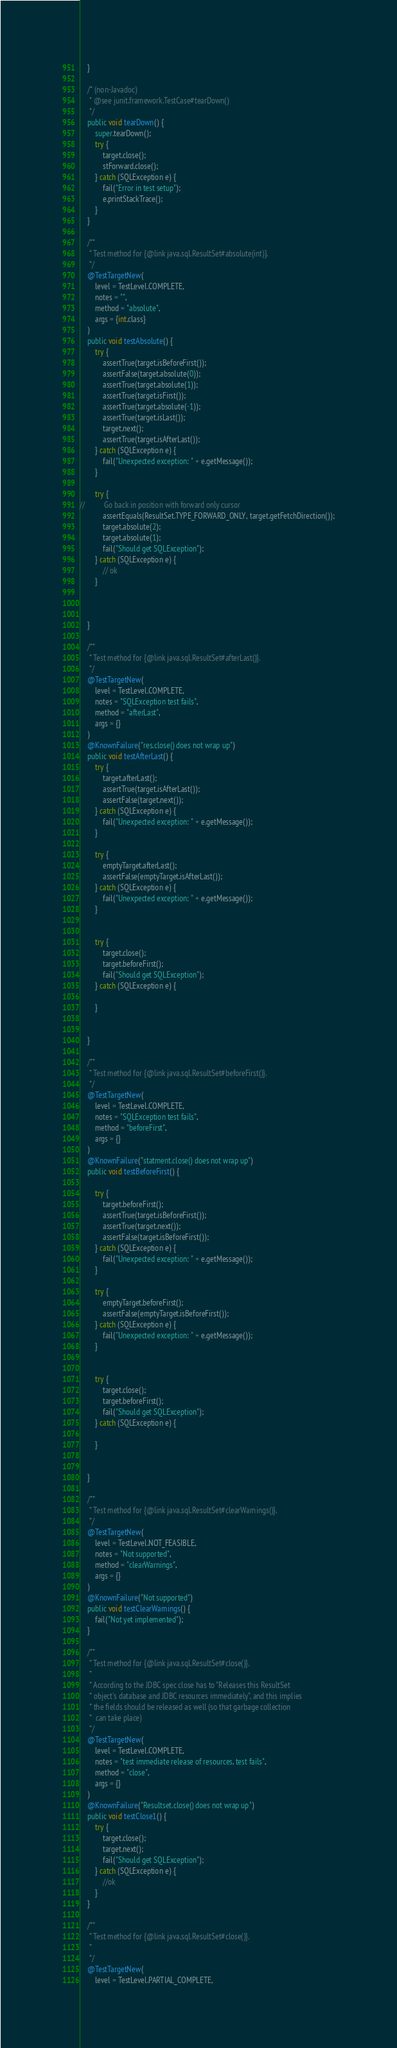<code> <loc_0><loc_0><loc_500><loc_500><_Java_>    }

    /* (non-Javadoc)
     * @see junit.framework.TestCase#tearDown()
     */
    public void tearDown() {
        super.tearDown();
        try {
            target.close();
            stForward.close();
        } catch (SQLException e) {
            fail("Error in test setup");
            e.printStackTrace();
        }
    }

    /**
     * Test method for {@link java.sql.ResultSet#absolute(int)}.
     */
    @TestTargetNew(
        level = TestLevel.COMPLETE,
        notes = "",
        method = "absolute",
        args = {int.class}
    )
    public void testAbsolute() {
        try {
            assertTrue(target.isBeforeFirst());
            assertFalse(target.absolute(0));
            assertTrue(target.absolute(1));
            assertTrue(target.isFirst());
            assertTrue(target.absolute(-1));
            assertTrue(target.isLast());
            target.next();
            assertTrue(target.isAfterLast());
        } catch (SQLException e) {
            fail("Unexpected exception: " + e.getMessage());
        }
        
        try {
//          Go back in position with forward only cursor
            assertEquals(ResultSet.TYPE_FORWARD_ONLY, target.getFetchDirection());
            target.absolute(2);
            target.absolute(1);
            fail("Should get SQLException");
        } catch (SQLException e) {
            // ok
        }
        
        
        
    }

    /**
     * Test method for {@link java.sql.ResultSet#afterLast()}.
     */
    @TestTargetNew(
        level = TestLevel.COMPLETE,
        notes = "SQLException test fails",
        method = "afterLast",
        args = {}
    )
    @KnownFailure("res.close() does not wrap up")
    public void testAfterLast() {
        try {
            target.afterLast();
            assertTrue(target.isAfterLast());
            assertFalse(target.next());
        } catch (SQLException e) {
            fail("Unexpected exception: " + e.getMessage());
        }
        
        try {
            emptyTarget.afterLast();
            assertFalse(emptyTarget.isAfterLast());
        } catch (SQLException e) {
            fail("Unexpected exception: " + e.getMessage());
        }
        
        
        try {
            target.close();
            target.beforeFirst();
            fail("Should get SQLException");
        } catch (SQLException e) {
            
        }
        
        
    }

    /**
     * Test method for {@link java.sql.ResultSet#beforeFirst()}.
     */
    @TestTargetNew(
        level = TestLevel.COMPLETE,
        notes = "SQLException test fails",
        method = "beforeFirst",
        args = {}
    )
    @KnownFailure("statment.close() does not wrap up")
    public void testBeforeFirst() {
        
        try {
            target.beforeFirst();
            assertTrue(target.isBeforeFirst());
            assertTrue(target.next());
            assertFalse(target.isBeforeFirst());
        } catch (SQLException e) {
            fail("Unexpected exception: " + e.getMessage());
        }
        
        try {
            emptyTarget.beforeFirst();
            assertFalse(emptyTarget.isBeforeFirst());
        } catch (SQLException e) {
            fail("Unexpected exception: " + e.getMessage());
        }
        
        
        try {
            target.close();
            target.beforeFirst();
            fail("Should get SQLException");
        } catch (SQLException e) {
            
        }
        
       
    }

    /**
     * Test method for {@link java.sql.ResultSet#clearWarnings()}.
     */
    @TestTargetNew(
        level = TestLevel.NOT_FEASIBLE,
        notes = "Not supported",
        method = "clearWarnings",
        args = {}
    )
    @KnownFailure("Not supported")
    public void testClearWarnings() {
        fail("Not yet implemented");
    }

    /**
     * Test method for {@link java.sql.ResultSet#close()}. 
     * 
     * According to the JDBC spec close has to "Releases this ResultSet
     * object's database and JDBC resources immediately", and this implies
     * the fields should be released as well (so that garbage collection 
     *  can take place)
     */
    @TestTargetNew(
        level = TestLevel.COMPLETE,
        notes = "test immediate release of resources, test fails",
        method = "close",
        args = {}
    )
    @KnownFailure("Resultset.close() does not wrap up")
    public void testClose1() {
        try {
            target.close();
            target.next();
            fail("Should get SQLException");
        } catch (SQLException e) {
            //ok
        }
    }
    
    /**
     * Test method for {@link java.sql.ResultSet#close()}. 
     * 
     */
    @TestTargetNew(
        level = TestLevel.PARTIAL_COMPLETE,</code> 